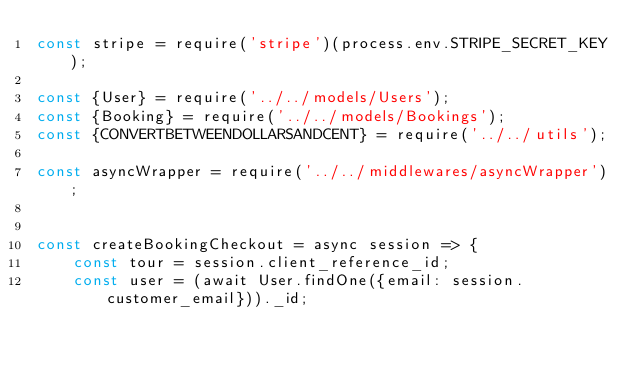Convert code to text. <code><loc_0><loc_0><loc_500><loc_500><_JavaScript_>const stripe = require('stripe')(process.env.STRIPE_SECRET_KEY);

const {User} = require('../../models/Users');
const {Booking} = require('../../models/Bookings');
const {CONVERTBETWEENDOLLARSANDCENT} = require('../../utils');

const asyncWrapper = require('../../middlewares/asyncWrapper');


const createBookingCheckout = async session => {
    const tour = session.client_reference_id;
    const user = (await User.findOne({email: session.customer_email}))._id;</code> 